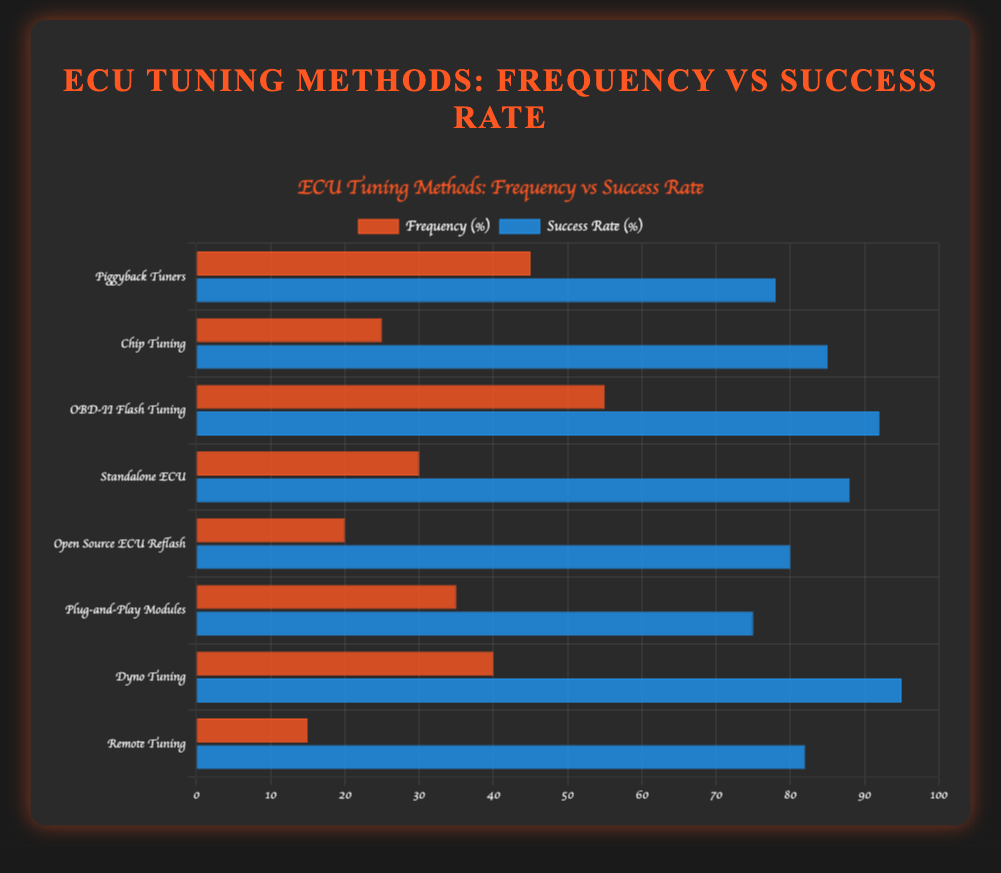Which method has the highest success rate? From the bar lengths representing success rates, OBD-II Flash Tuning has the highest success rate at 92%.
Answer: OBD-II Flash Tuning Which ECU tuning method is used most often? By comparing the lengths of the frequency bars, OBD-II Flash Tuning has the highest frequency at 55%.
Answer: OBD-II Flash Tuning What is the combined frequency of 'Standalone ECU' and 'Plug-and-Play Modules'? The frequency of 'Standalone ECU' is 30 and for 'Plug-and-Play Modules' is 35; thus, their combined frequency is 30 + 35 = 65.
Answer: 65 How much higher is the average success rate of 'Chip Tuning' and 'Dyno Tuning' compared to 'Remote Tuning'? The average success rate for 'Chip Tuning' and 'Dyno Tuning' is (85 + 95) / 2 = 90%. This is compared to 'Remote Tuning,' which has a success rate of 82%. The difference is 90% - 82% = 8%.
Answer: 8% Which method has a higher success rate, 'Piggyback Tuners' or 'Standalone ECU'? Compare their success rates: 'Piggyback Tuners' have a success rate of 78%, while 'Standalone ECU' has a success rate of 88%. Hence, 'Standalone ECU' has a higher success rate.
Answer: Standalone ECU Among the methods with a frequency above 30, which has the lowest success rate? The methods with a frequency above 30 are 'Piggyback Tuners,' 'OBD-II Flash Tuning,' 'Standalone ECU,' and 'Plug-and-Play Modules.' The corresponding success rates are 78%, 92%, 88%, and 75%, respectively. So, 'Plug-and-Play Modules' have the lowest success rate.
Answer: Plug-and-Play Modules What's the frequency difference between the most and least used tuning methods? The most used method is 'OBD-II Flash Tuning' with a frequency of 55, and the least used is 'Remote Tuning' with a frequency of 15. Thus, the difference is 55 - 15 = 40.
Answer: 40 How does the success rate of 'Dyno Tuning' compare to 'Open Source ECU Reflash'? 'Dyno Tuning' has a success rate of 95% while 'Open Source ECU Reflash' has a success rate of 80%. Therefore, 'Dyno Tuning' has a 15% higher success rate.
Answer: 15% How many methods have a success rate above 80%? Calculate the methods with success rates above 80%: 'Chip Tuning,' 'OBD-II Flash Tuning,' 'Standalone ECU,' 'Dyno Tuning,' and 'Remote Tuning.' The count is 5 methods.
Answer: 5 Is 'Remote Tuning' more popular than 'Open Source ECU Reflash'? Compare their frequencies: 'Remote Tuning' has a frequency of 15, while 'Open Source ECU Reflash' has a frequency of 20. Thus, 'Remote Tuning' is less popular.
Answer: No 